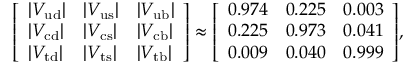Convert formula to latex. <formula><loc_0><loc_0><loc_500><loc_500>{ \left [ \begin{array} { l l l } { | V _ { u d } | } & { | V _ { u s } | } & { | V _ { u b } | } \\ { | V _ { c d } | } & { | V _ { c s } | } & { | V _ { c b } | } \\ { | V _ { t d } | } & { | V _ { t s } | } & { | V _ { t b } | } \end{array} \right ] } \approx { \left [ \begin{array} { l l l } { 0 . 9 7 4 } & { 0 . 2 2 5 } & { 0 . 0 0 3 } \\ { 0 . 2 2 5 } & { 0 . 9 7 3 } & { 0 . 0 4 1 } \\ { 0 . 0 0 9 } & { 0 . 0 4 0 } & { 0 . 9 9 9 } \end{array} \right ] } ,</formula> 